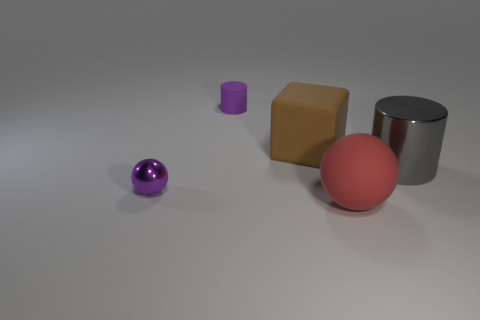Is there any other thing that is the same color as the tiny metal thing?
Offer a very short reply. Yes. What is the material of the other purple object that is the same shape as the big metal thing?
Keep it short and to the point. Rubber. How many other things are the same size as the brown matte block?
Your answer should be very brief. 2. What is the material of the large block?
Make the answer very short. Rubber. Is the number of metal balls behind the tiny purple cylinder greater than the number of gray cubes?
Provide a succinct answer. No. Are any blue rubber cylinders visible?
Your answer should be very brief. No. What number of other objects are the same shape as the brown object?
Your answer should be very brief. 0. There is a cylinder right of the rubber block; is it the same color as the rubber object in front of the gray metallic object?
Your answer should be compact. No. There is a purple thing that is behind the large object that is on the right side of the matte thing in front of the big gray thing; how big is it?
Give a very brief answer. Small. What shape is the object that is on the left side of the large brown block and in front of the small purple matte thing?
Your answer should be compact. Sphere. 